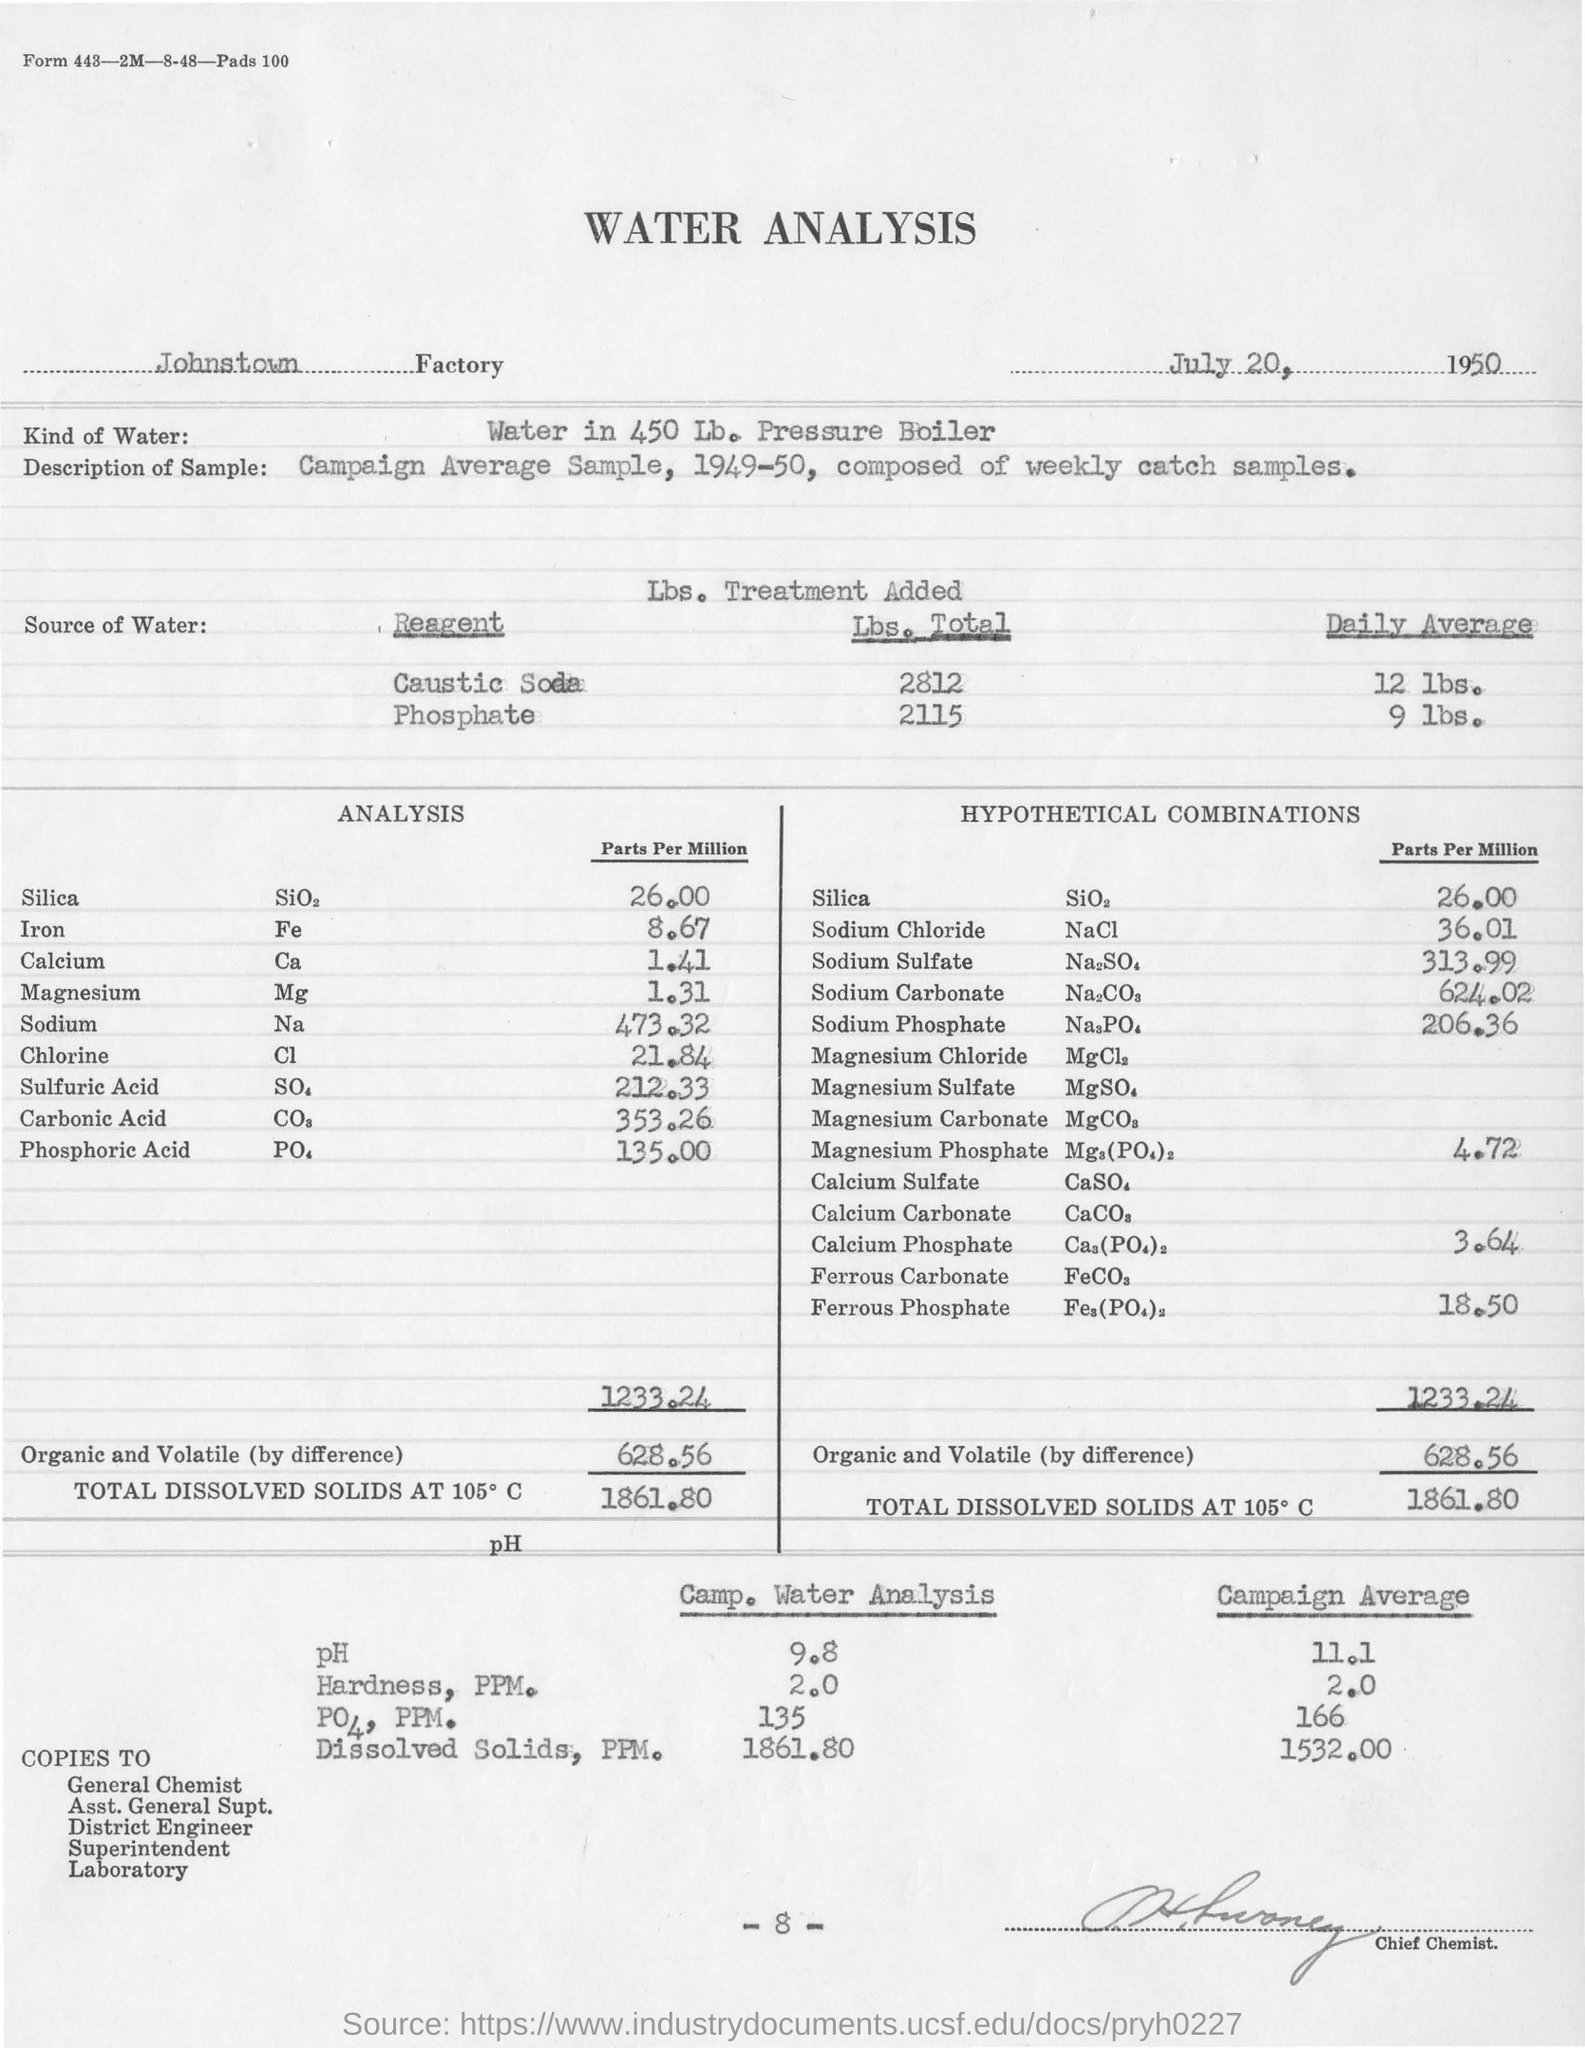Which factory is being considered for water analysis
Keep it short and to the point. Johnstown. What date is mentioned in the along side factory name
Your answer should be very brief. July 20, 1950. What analysis does main heading mention
Give a very brief answer. WATER. How much is ph in camp.water analysis
Offer a terse response. 9.8. 